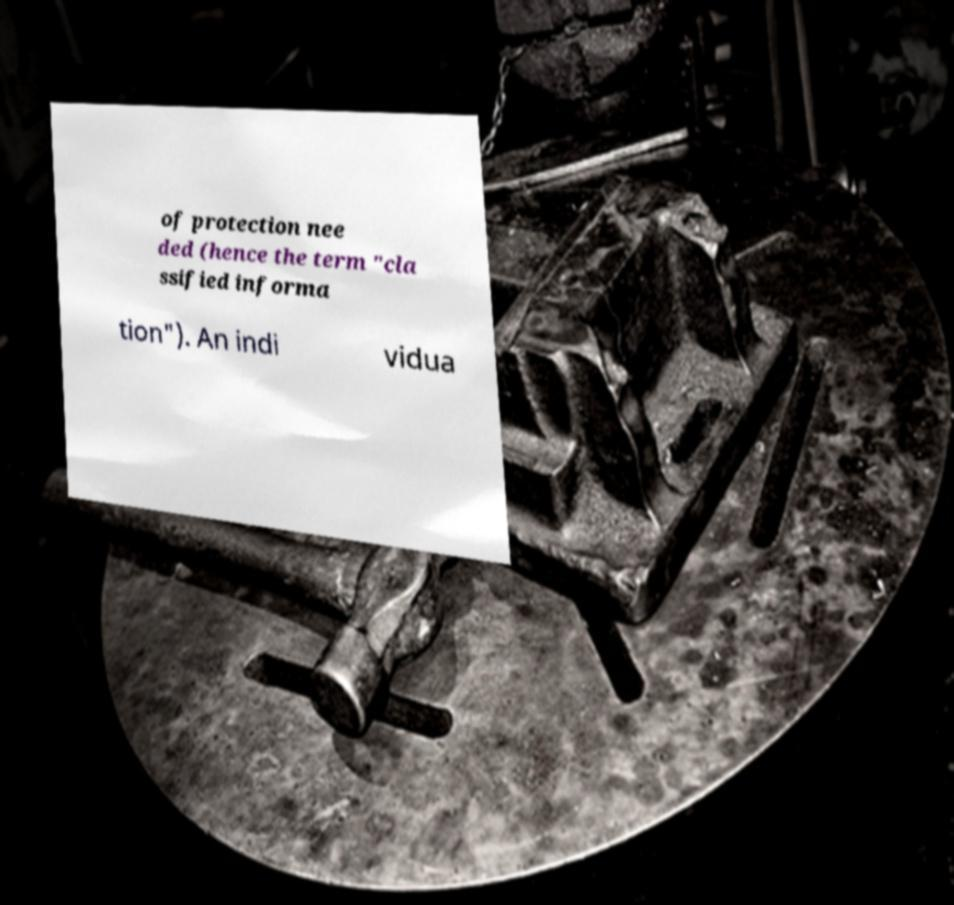Please identify and transcribe the text found in this image. of protection nee ded (hence the term "cla ssified informa tion"). An indi vidua 